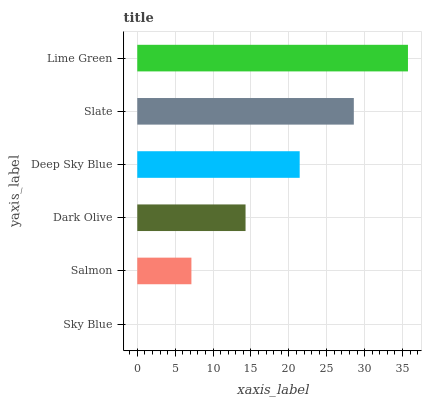Is Sky Blue the minimum?
Answer yes or no. Yes. Is Lime Green the maximum?
Answer yes or no. Yes. Is Salmon the minimum?
Answer yes or no. No. Is Salmon the maximum?
Answer yes or no. No. Is Salmon greater than Sky Blue?
Answer yes or no. Yes. Is Sky Blue less than Salmon?
Answer yes or no. Yes. Is Sky Blue greater than Salmon?
Answer yes or no. No. Is Salmon less than Sky Blue?
Answer yes or no. No. Is Deep Sky Blue the high median?
Answer yes or no. Yes. Is Dark Olive the low median?
Answer yes or no. Yes. Is Dark Olive the high median?
Answer yes or no. No. Is Slate the low median?
Answer yes or no. No. 